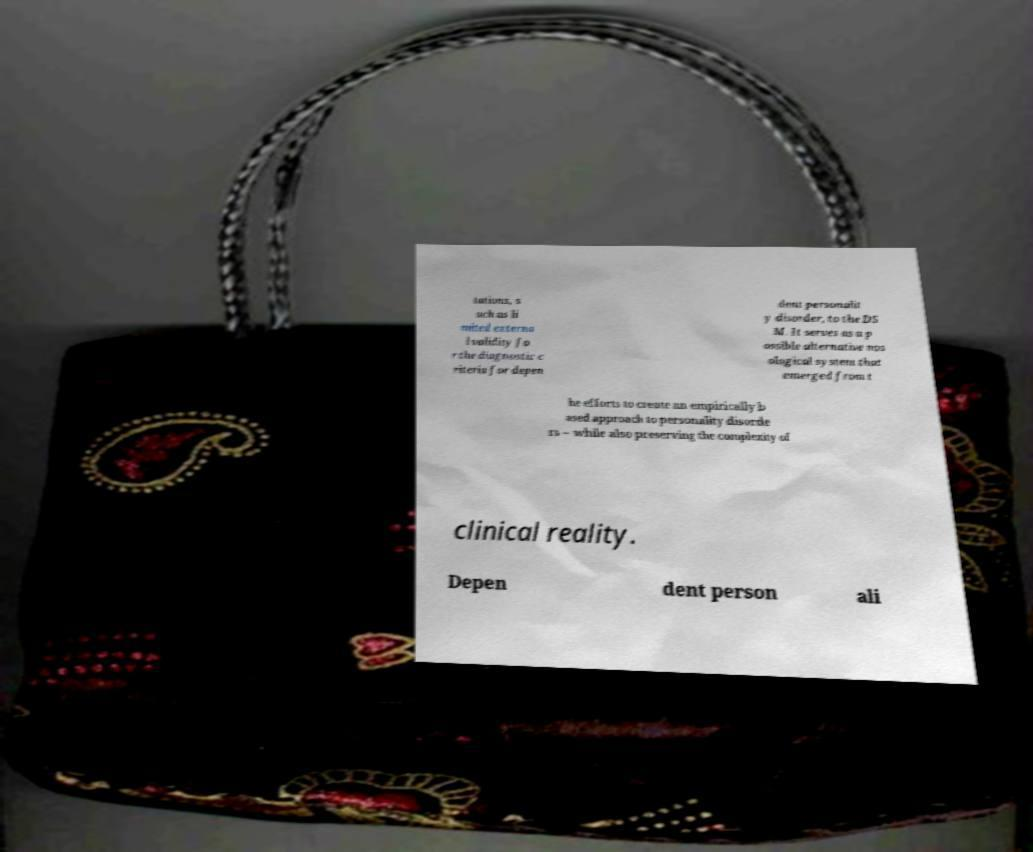What messages or text are displayed in this image? I need them in a readable, typed format. tations, s uch as li mited externa l validity fo r the diagnostic c riteria for depen dent personalit y disorder, to the DS M. It serves as a p ossible alternative nos ological system that emerged from t he efforts to create an empirically b ased approach to personality disorde rs – while also preserving the complexity of clinical reality. Depen dent person ali 